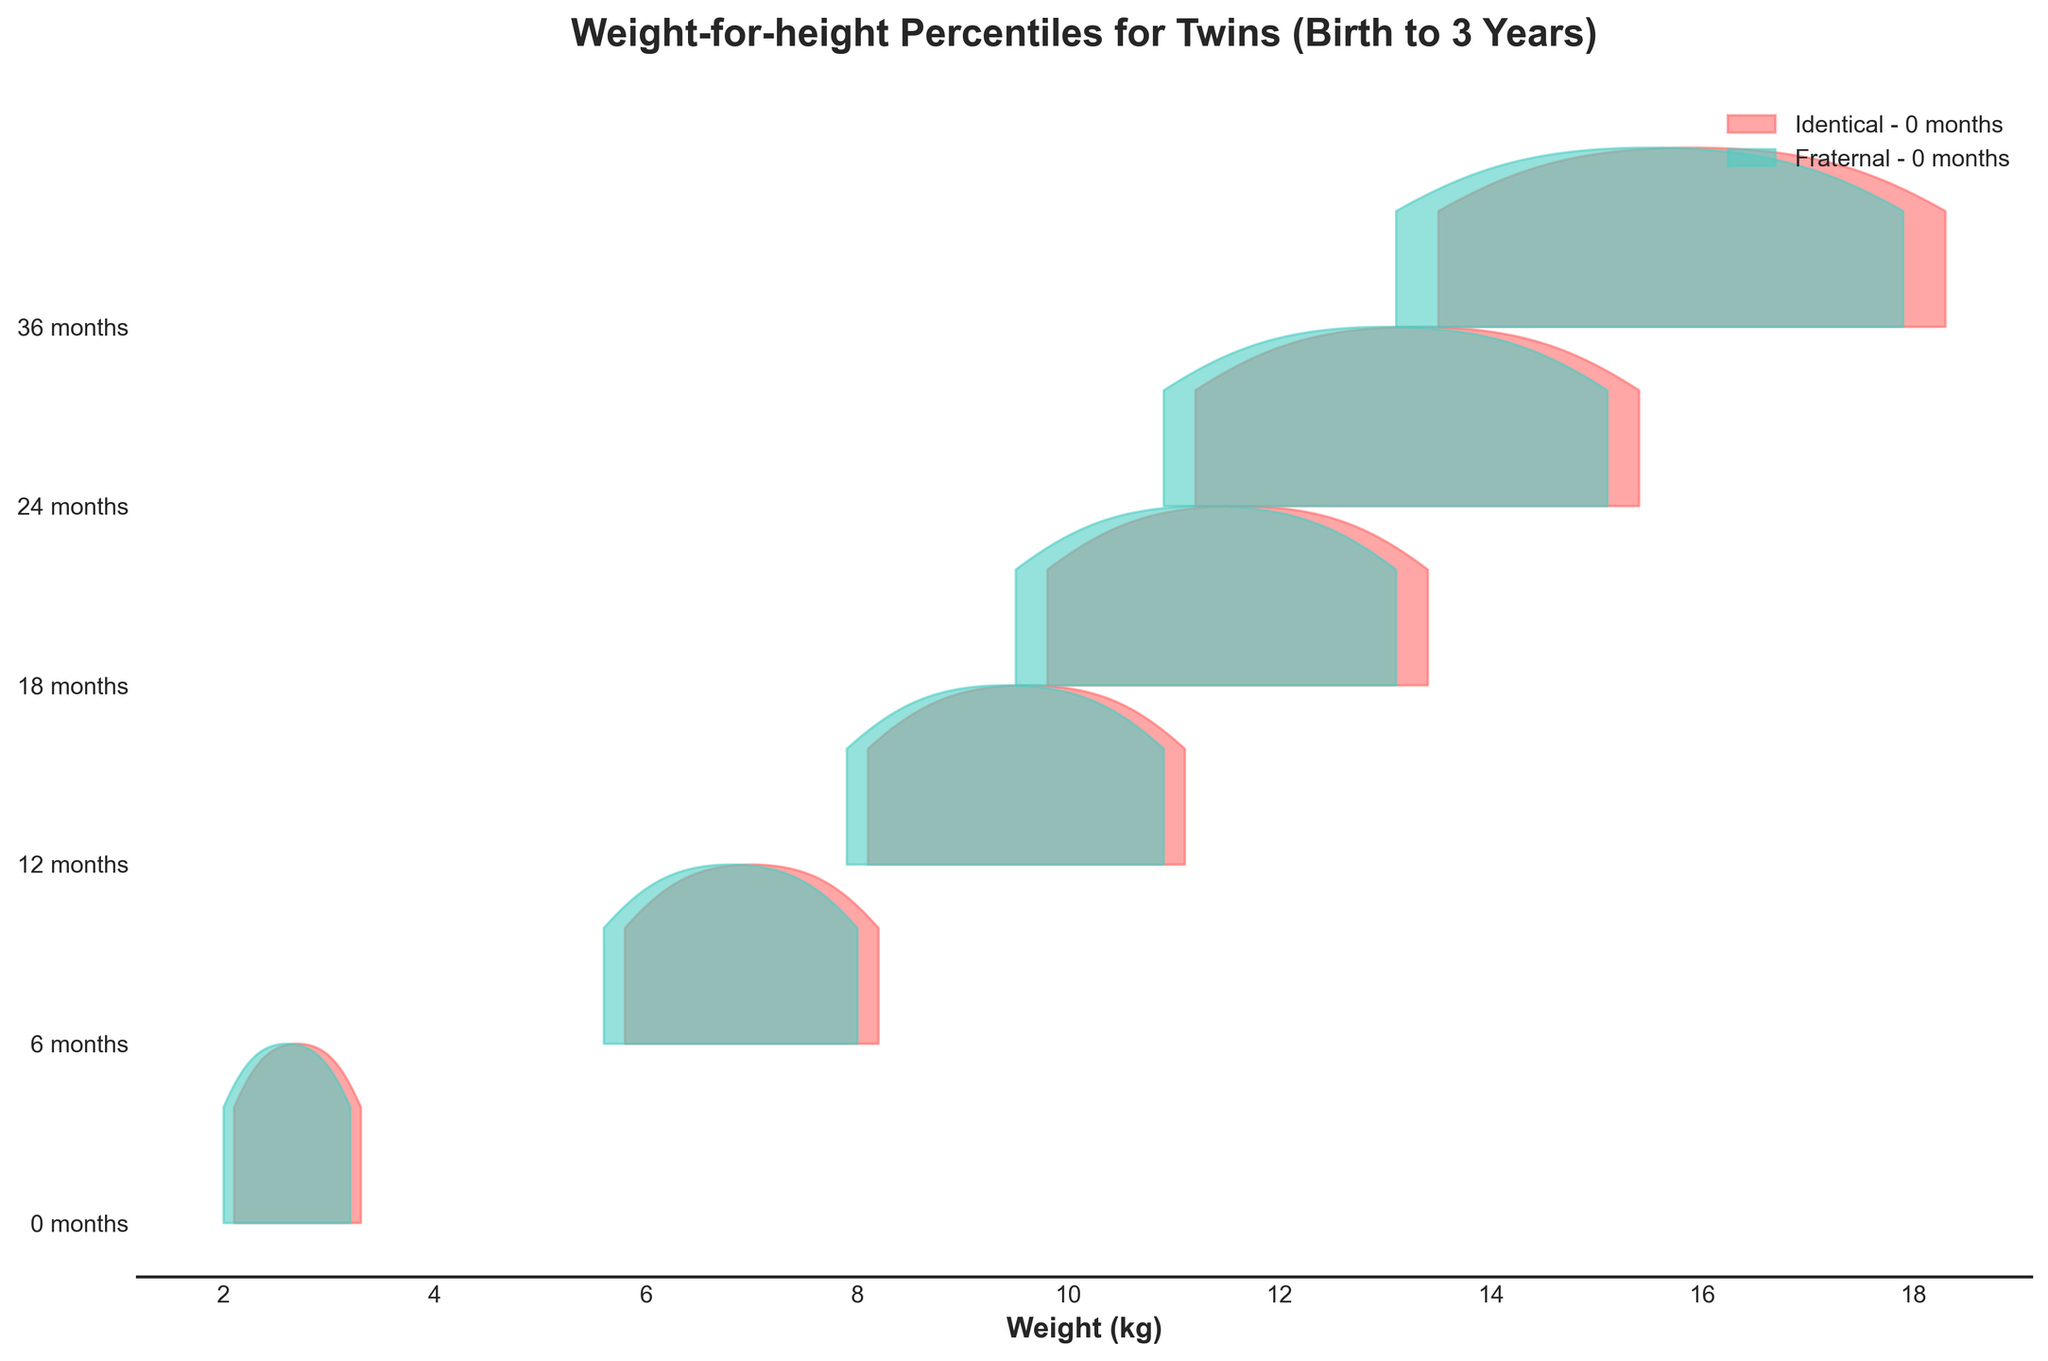what is the title of the plot? The title of the plot can be found at the top of the figure. It states what the plot is about. In this case, it is "Weight-for-height Percentiles for Twins (Birth to 3 Years)".
Answer: Weight-for-height Percentiles for Twins (Birth to 3 Years) What is the x-axis label in the plot? The x-axis label is provided below the horizontal axis of the plot and explains what the values on the x-axis represent. In this case, it is "Weight (kg)".
Answer: Weight (kg) Which age group has the highest weight distribution among identical twins? From the vertical position of the ridgelines corresponding to each age group, the ridgeline for 36 months appears highest up on the plot, indicating the older age group has higher weight values.
Answer: 36 months Which color represents fraternal twins in the plot? The plot uses different colors to represent different types of twins. The legend in the plot shows Fraternal twins are represented by a turquoise color.
Answer: Turquoise At what age do identical twins have their median weight around 13 kg? The median value on the plot for the different age groups can be compared. At 24 months, the weight for Identical twins is around 13 kg.
Answer: 24 months At 12 months, which type of twins has higher percentile values for weight? To determine this, compare the distributions of weights at 12 months for both Identical and Fraternal twins. Identical twins have consistently higher values across all percentiles.
Answer: Identical twins What is the central tendency of the weight for fraternal twins at 3 years (36 months)? The central tendency can be observed where the distribution is centered. For fraternal twins at 36 months, the median value is at 15.5 kg.
Answer: 15.5 kg How do the 90th percentile weights compare for fraternal and identical twins at 18 months? At 18 months, comparing the 90th percentile weight values for both types shows that fraternal twins have a value of 12.5 kg while identical twins have 12.8 kg.
Answer: Identical twins have a slightly higher 90th percentile at 18 months Which age group for fraternal twins are represented by the second ridgeline from the bottom in the plot? Observing the vertical order of the ridgelines, the second ridgeline from the bottom represents fraternal twins at 6 months old.
Answer: 6 months Are there any age groups where the weight distribution overlaps significantly between identical and fraternal twins? Overlapping distributions can be observed by looking at how closely the ridgelines for the two types of twins lie, especially around their peaks. Around the second lowest ridgeline for both types (6 months), we see notable overlap.
Answer: 6 months 